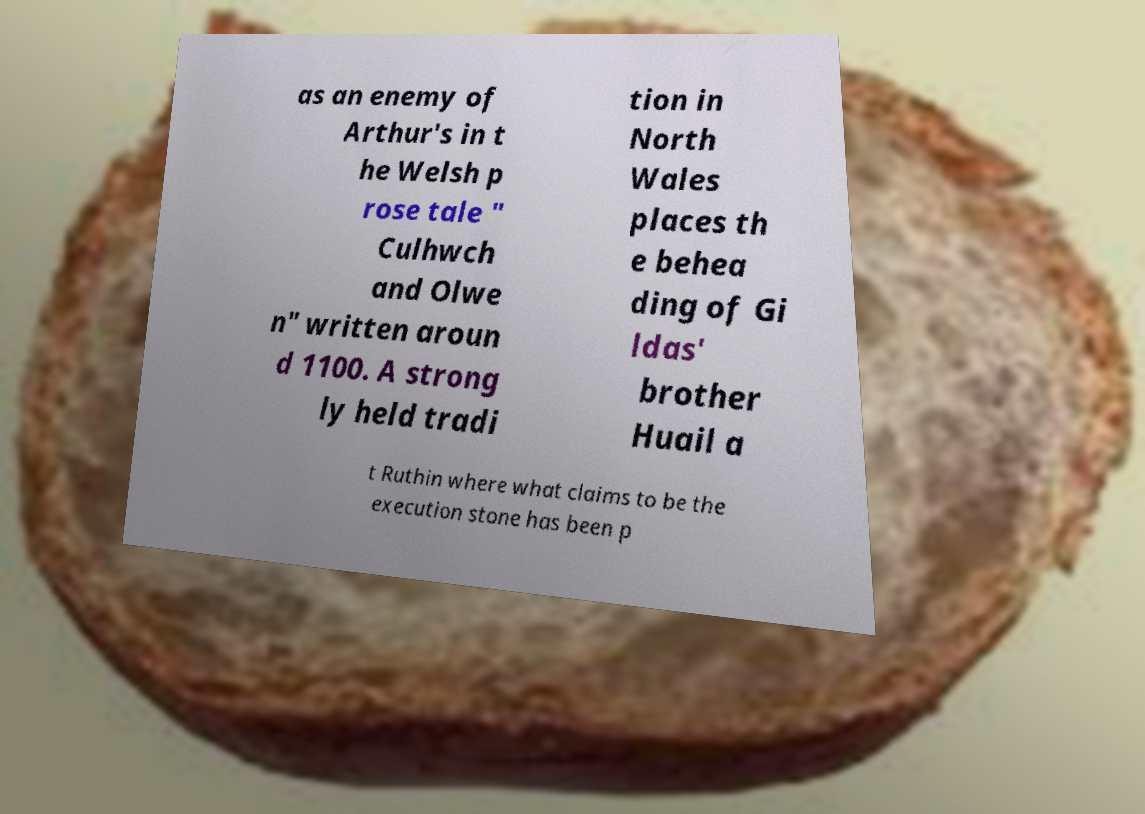Please read and relay the text visible in this image. What does it say? The text in the image discusses a character from Welsh mythology as depicted in the prose tale 'Culhwch and Olwen', which was written around 1100. It mentions a tradition in North Wales regarding the beheading of Gildas' brother Huail in Ruthin, near an alleged execution stone. 